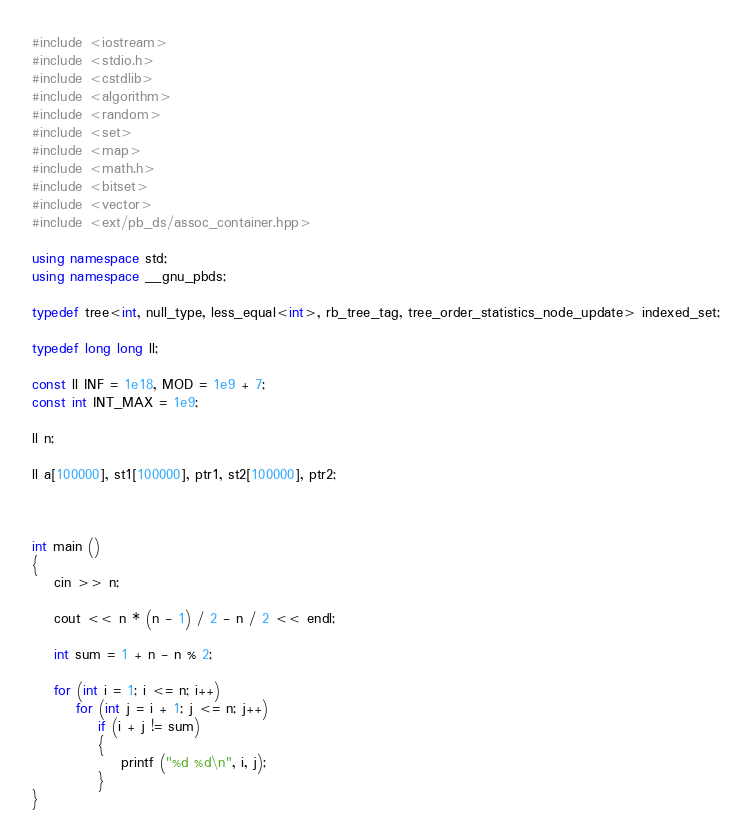<code> <loc_0><loc_0><loc_500><loc_500><_C++_>#include <iostream>
#include <stdio.h>
#include <cstdlib>
#include <algorithm>
#include <random>
#include <set>
#include <map>
#include <math.h>
#include <bitset>
#include <vector>
#include <ext/pb_ds/assoc_container.hpp>

using namespace std;
using namespace __gnu_pbds;

typedef tree<int, null_type, less_equal<int>, rb_tree_tag, tree_order_statistics_node_update> indexed_set;

typedef long long ll;

const ll INF = 1e18, MOD = 1e9 + 7;
const int INT_MAX = 1e9;

ll n;

ll a[100000], st1[100000], ptr1, st2[100000], ptr2;



int main () 
{
	cin >> n;

	cout << n * (n - 1) / 2 - n / 2 << endl;

	int sum = 1 + n - n % 2;

	for (int i = 1; i <= n; i++)
		for (int j = i + 1; j <= n; j++)
			if (i + j != sum)
			{
				printf ("%d %d\n", i, j);
			}
}</code> 